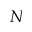<formula> <loc_0><loc_0><loc_500><loc_500>N</formula> 